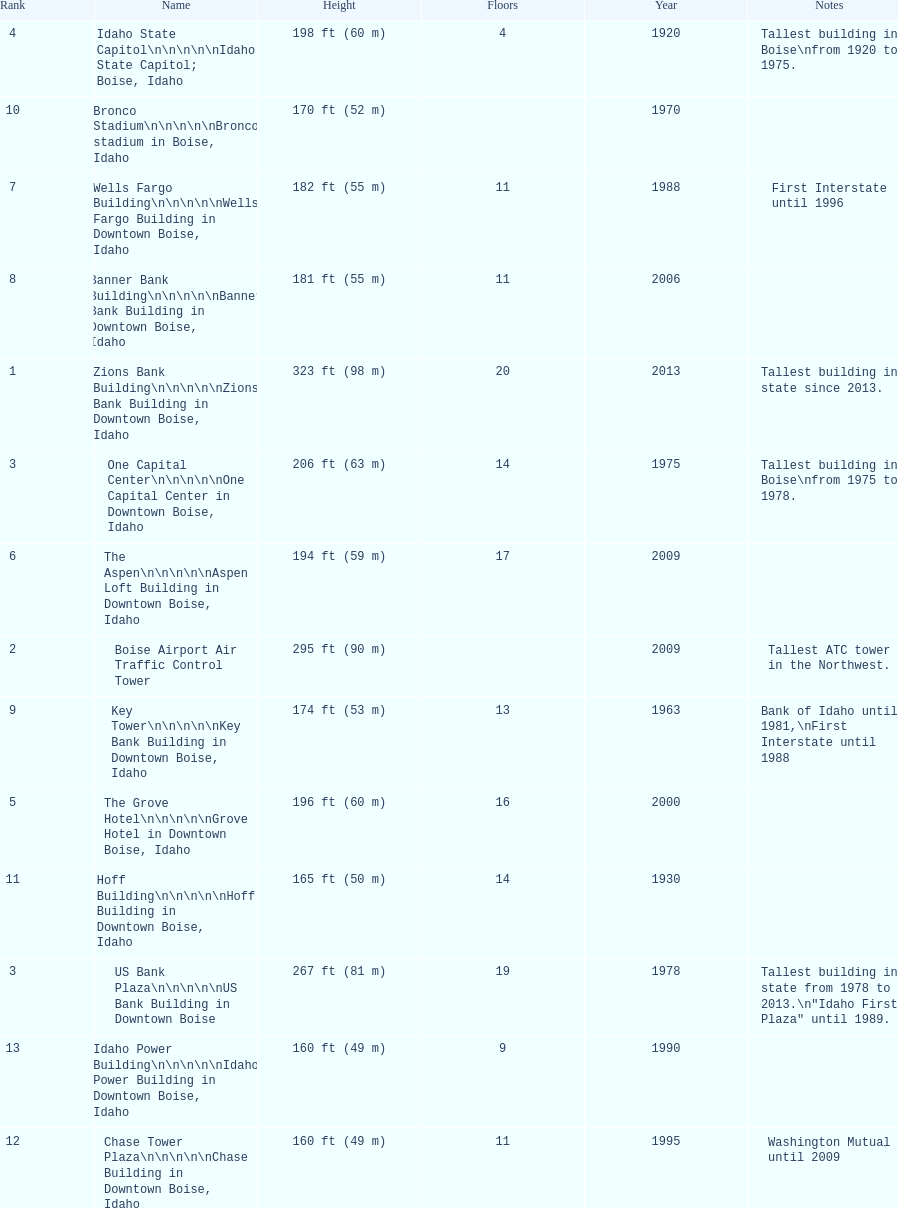Which building has the most floors according to this chart? Zions Bank Building. 